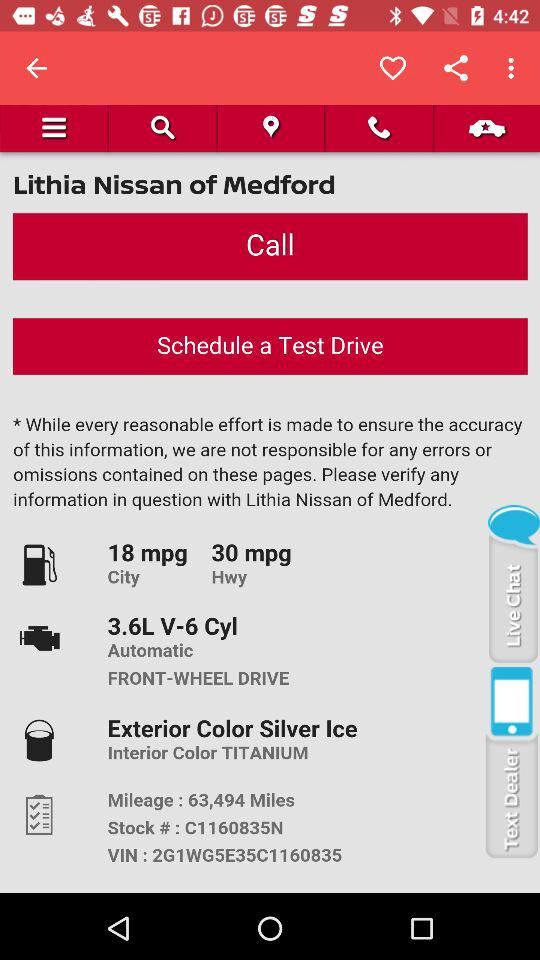What is the exterior color? The exterior color is Silver Ice. 